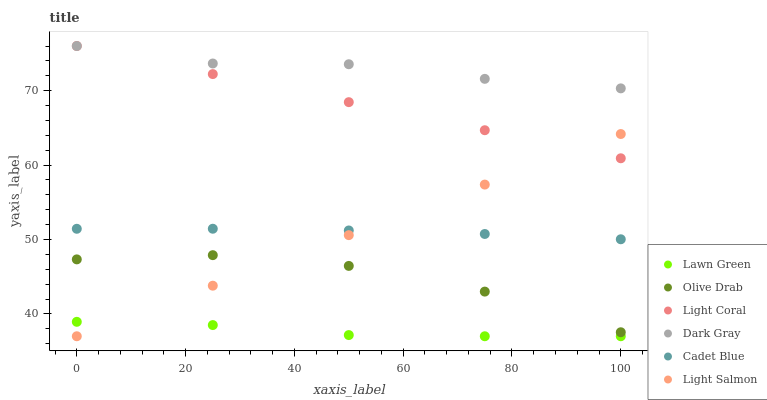Does Lawn Green have the minimum area under the curve?
Answer yes or no. Yes. Does Dark Gray have the maximum area under the curve?
Answer yes or no. Yes. Does Light Salmon have the minimum area under the curve?
Answer yes or no. No. Does Light Salmon have the maximum area under the curve?
Answer yes or no. No. Is Light Salmon the smoothest?
Answer yes or no. Yes. Is Olive Drab the roughest?
Answer yes or no. Yes. Is Cadet Blue the smoothest?
Answer yes or no. No. Is Cadet Blue the roughest?
Answer yes or no. No. Does Lawn Green have the lowest value?
Answer yes or no. Yes. Does Cadet Blue have the lowest value?
Answer yes or no. No. Does Dark Gray have the highest value?
Answer yes or no. Yes. Does Light Salmon have the highest value?
Answer yes or no. No. Is Olive Drab less than Light Coral?
Answer yes or no. Yes. Is Olive Drab greater than Lawn Green?
Answer yes or no. Yes. Does Cadet Blue intersect Light Salmon?
Answer yes or no. Yes. Is Cadet Blue less than Light Salmon?
Answer yes or no. No. Is Cadet Blue greater than Light Salmon?
Answer yes or no. No. Does Olive Drab intersect Light Coral?
Answer yes or no. No. 